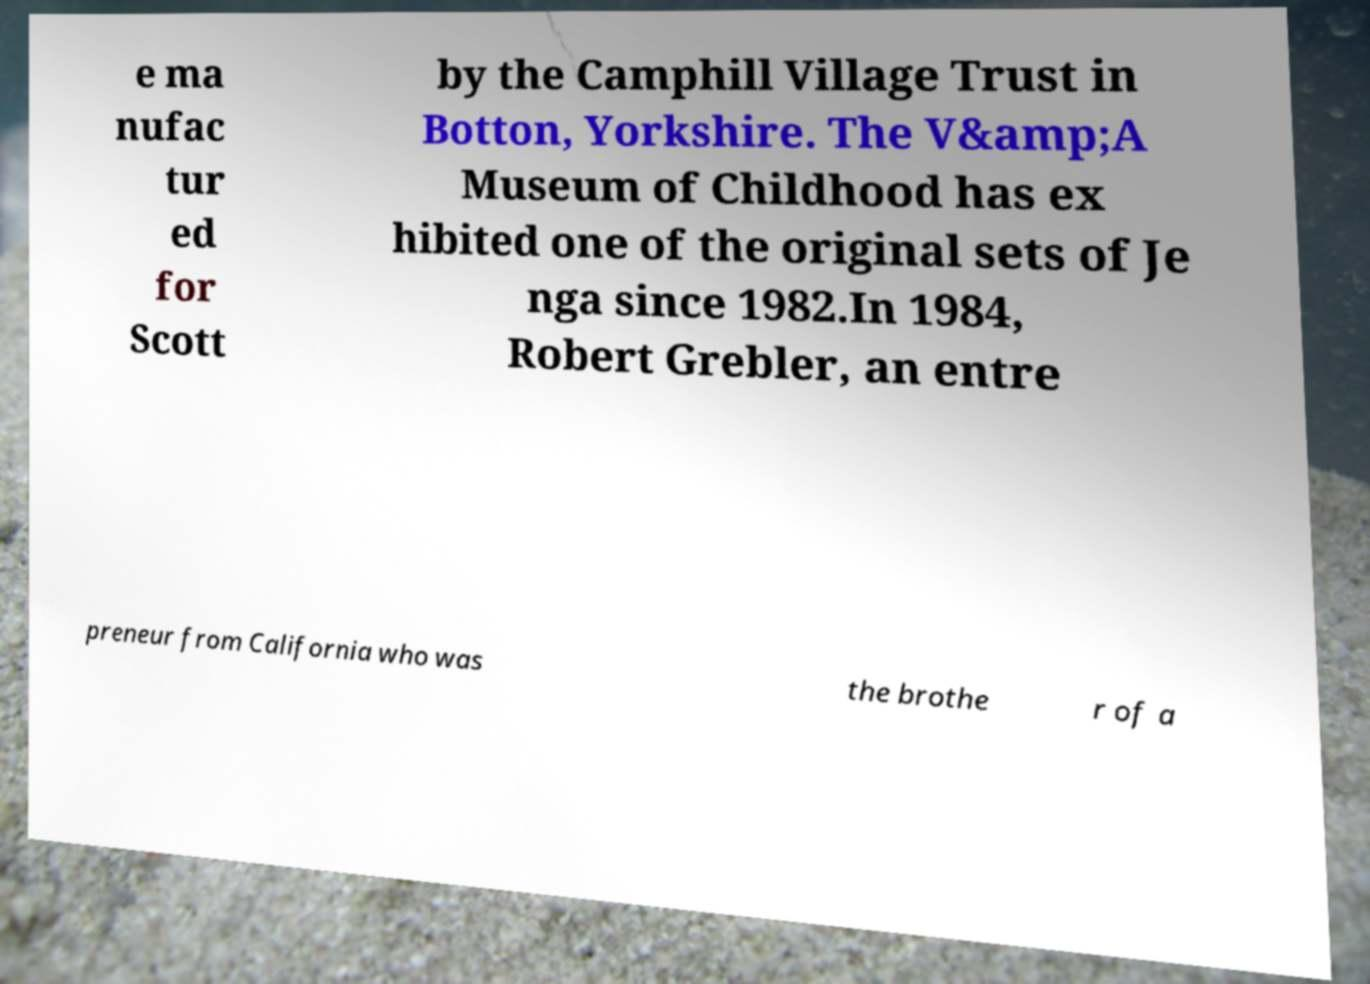Could you extract and type out the text from this image? e ma nufac tur ed for Scott by the Camphill Village Trust in Botton, Yorkshire. The V&amp;A Museum of Childhood has ex hibited one of the original sets of Je nga since 1982.In 1984, Robert Grebler, an entre preneur from California who was the brothe r of a 